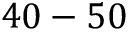<formula> <loc_0><loc_0><loc_500><loc_500>4 0 - 5 0</formula> 